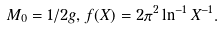Convert formula to latex. <formula><loc_0><loc_0><loc_500><loc_500>M _ { 0 } = 1 / 2 g , f ( X ) = 2 \pi ^ { 2 } \ln ^ { - 1 } X ^ { - 1 } .</formula> 